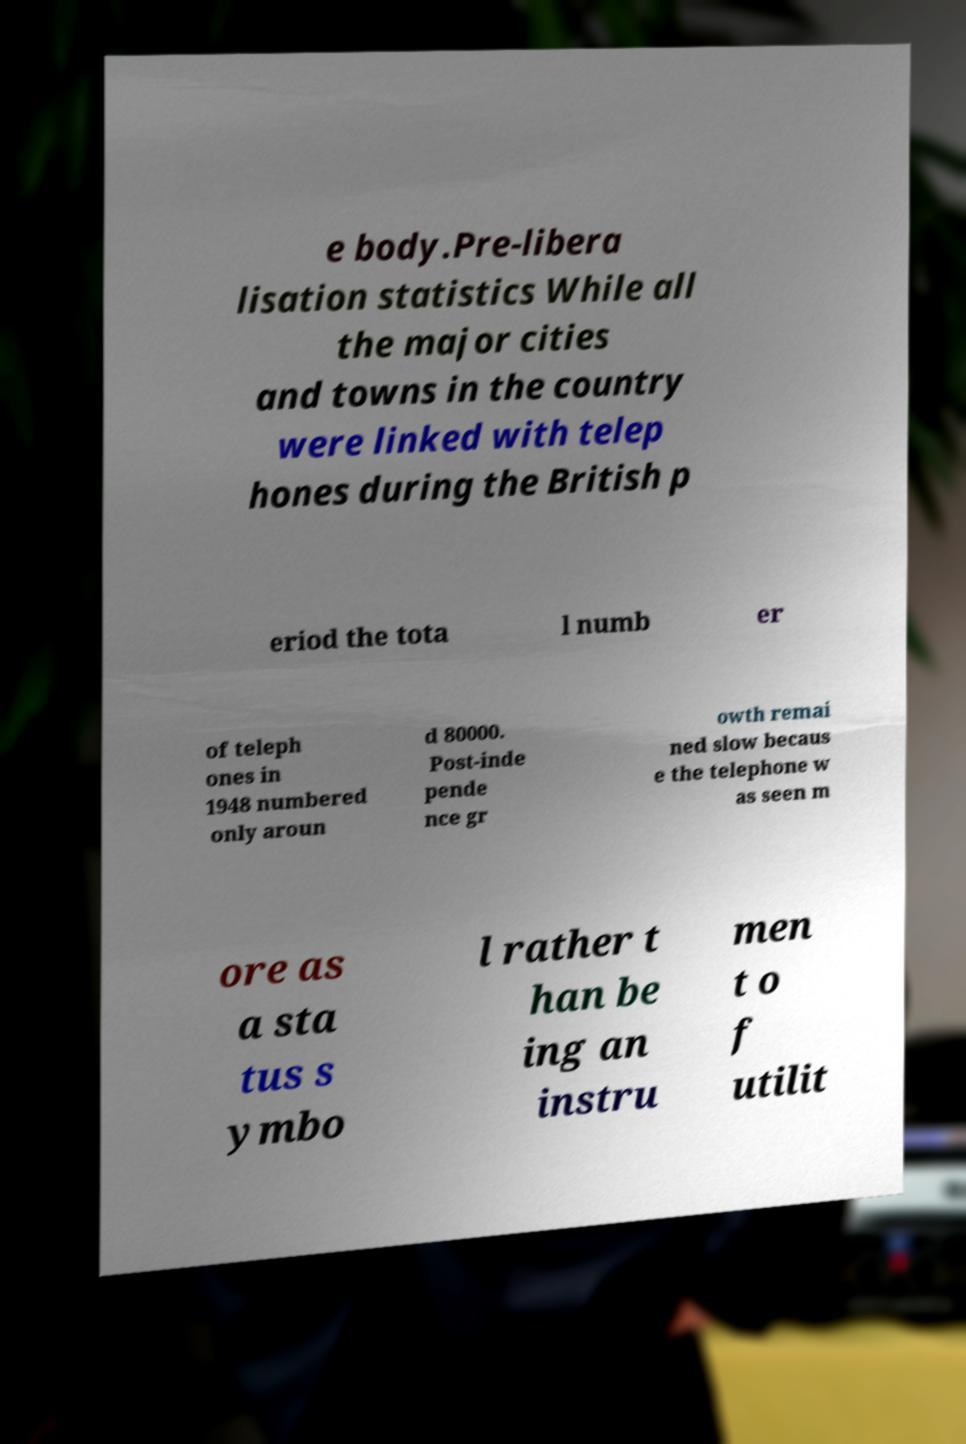Can you read and provide the text displayed in the image?This photo seems to have some interesting text. Can you extract and type it out for me? e body.Pre-libera lisation statistics While all the major cities and towns in the country were linked with telep hones during the British p eriod the tota l numb er of teleph ones in 1948 numbered only aroun d 80000. Post-inde pende nce gr owth remai ned slow becaus e the telephone w as seen m ore as a sta tus s ymbo l rather t han be ing an instru men t o f utilit 